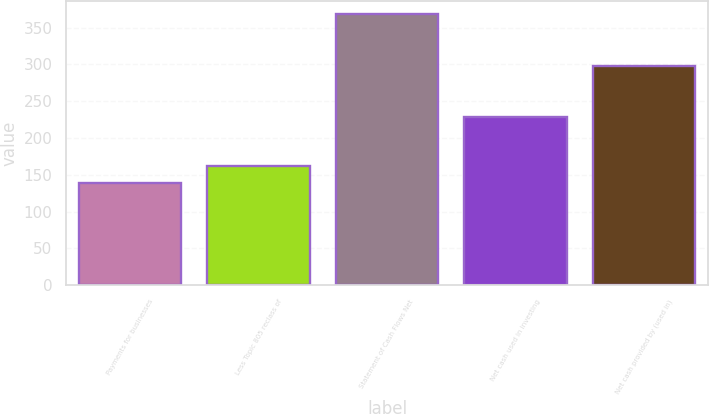Convert chart to OTSL. <chart><loc_0><loc_0><loc_500><loc_500><bar_chart><fcel>Payments for businesses<fcel>Less Topic 805 reclass of<fcel>Statement of Cash Flows Net<fcel>Net cash used in investing<fcel>Net cash provided by (used in)<nl><fcel>138.8<fcel>161.72<fcel>368<fcel>229.2<fcel>298.1<nl></chart> 